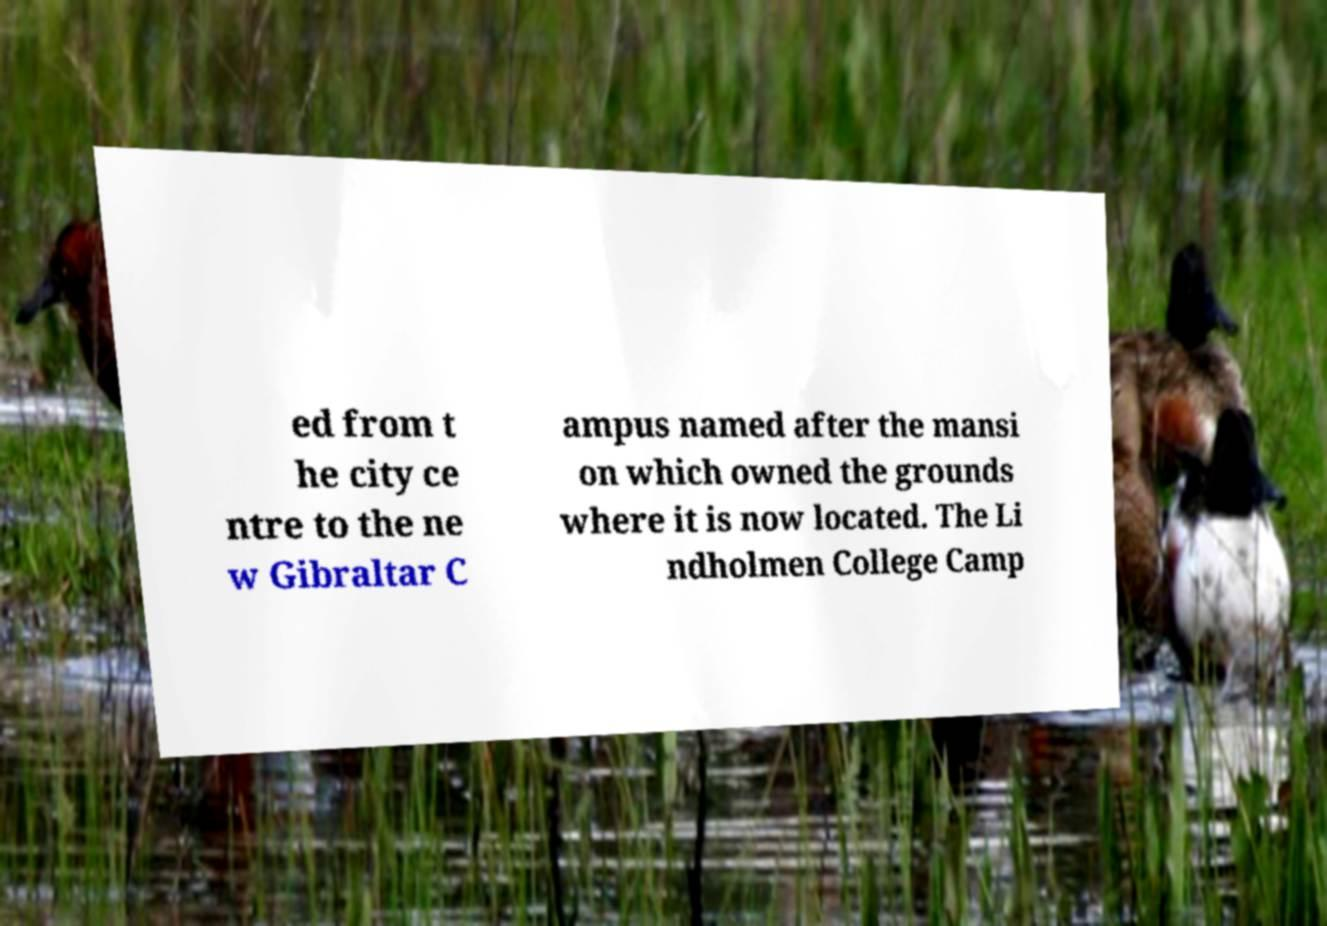Please read and relay the text visible in this image. What does it say? ed from t he city ce ntre to the ne w Gibraltar C ampus named after the mansi on which owned the grounds where it is now located. The Li ndholmen College Camp 